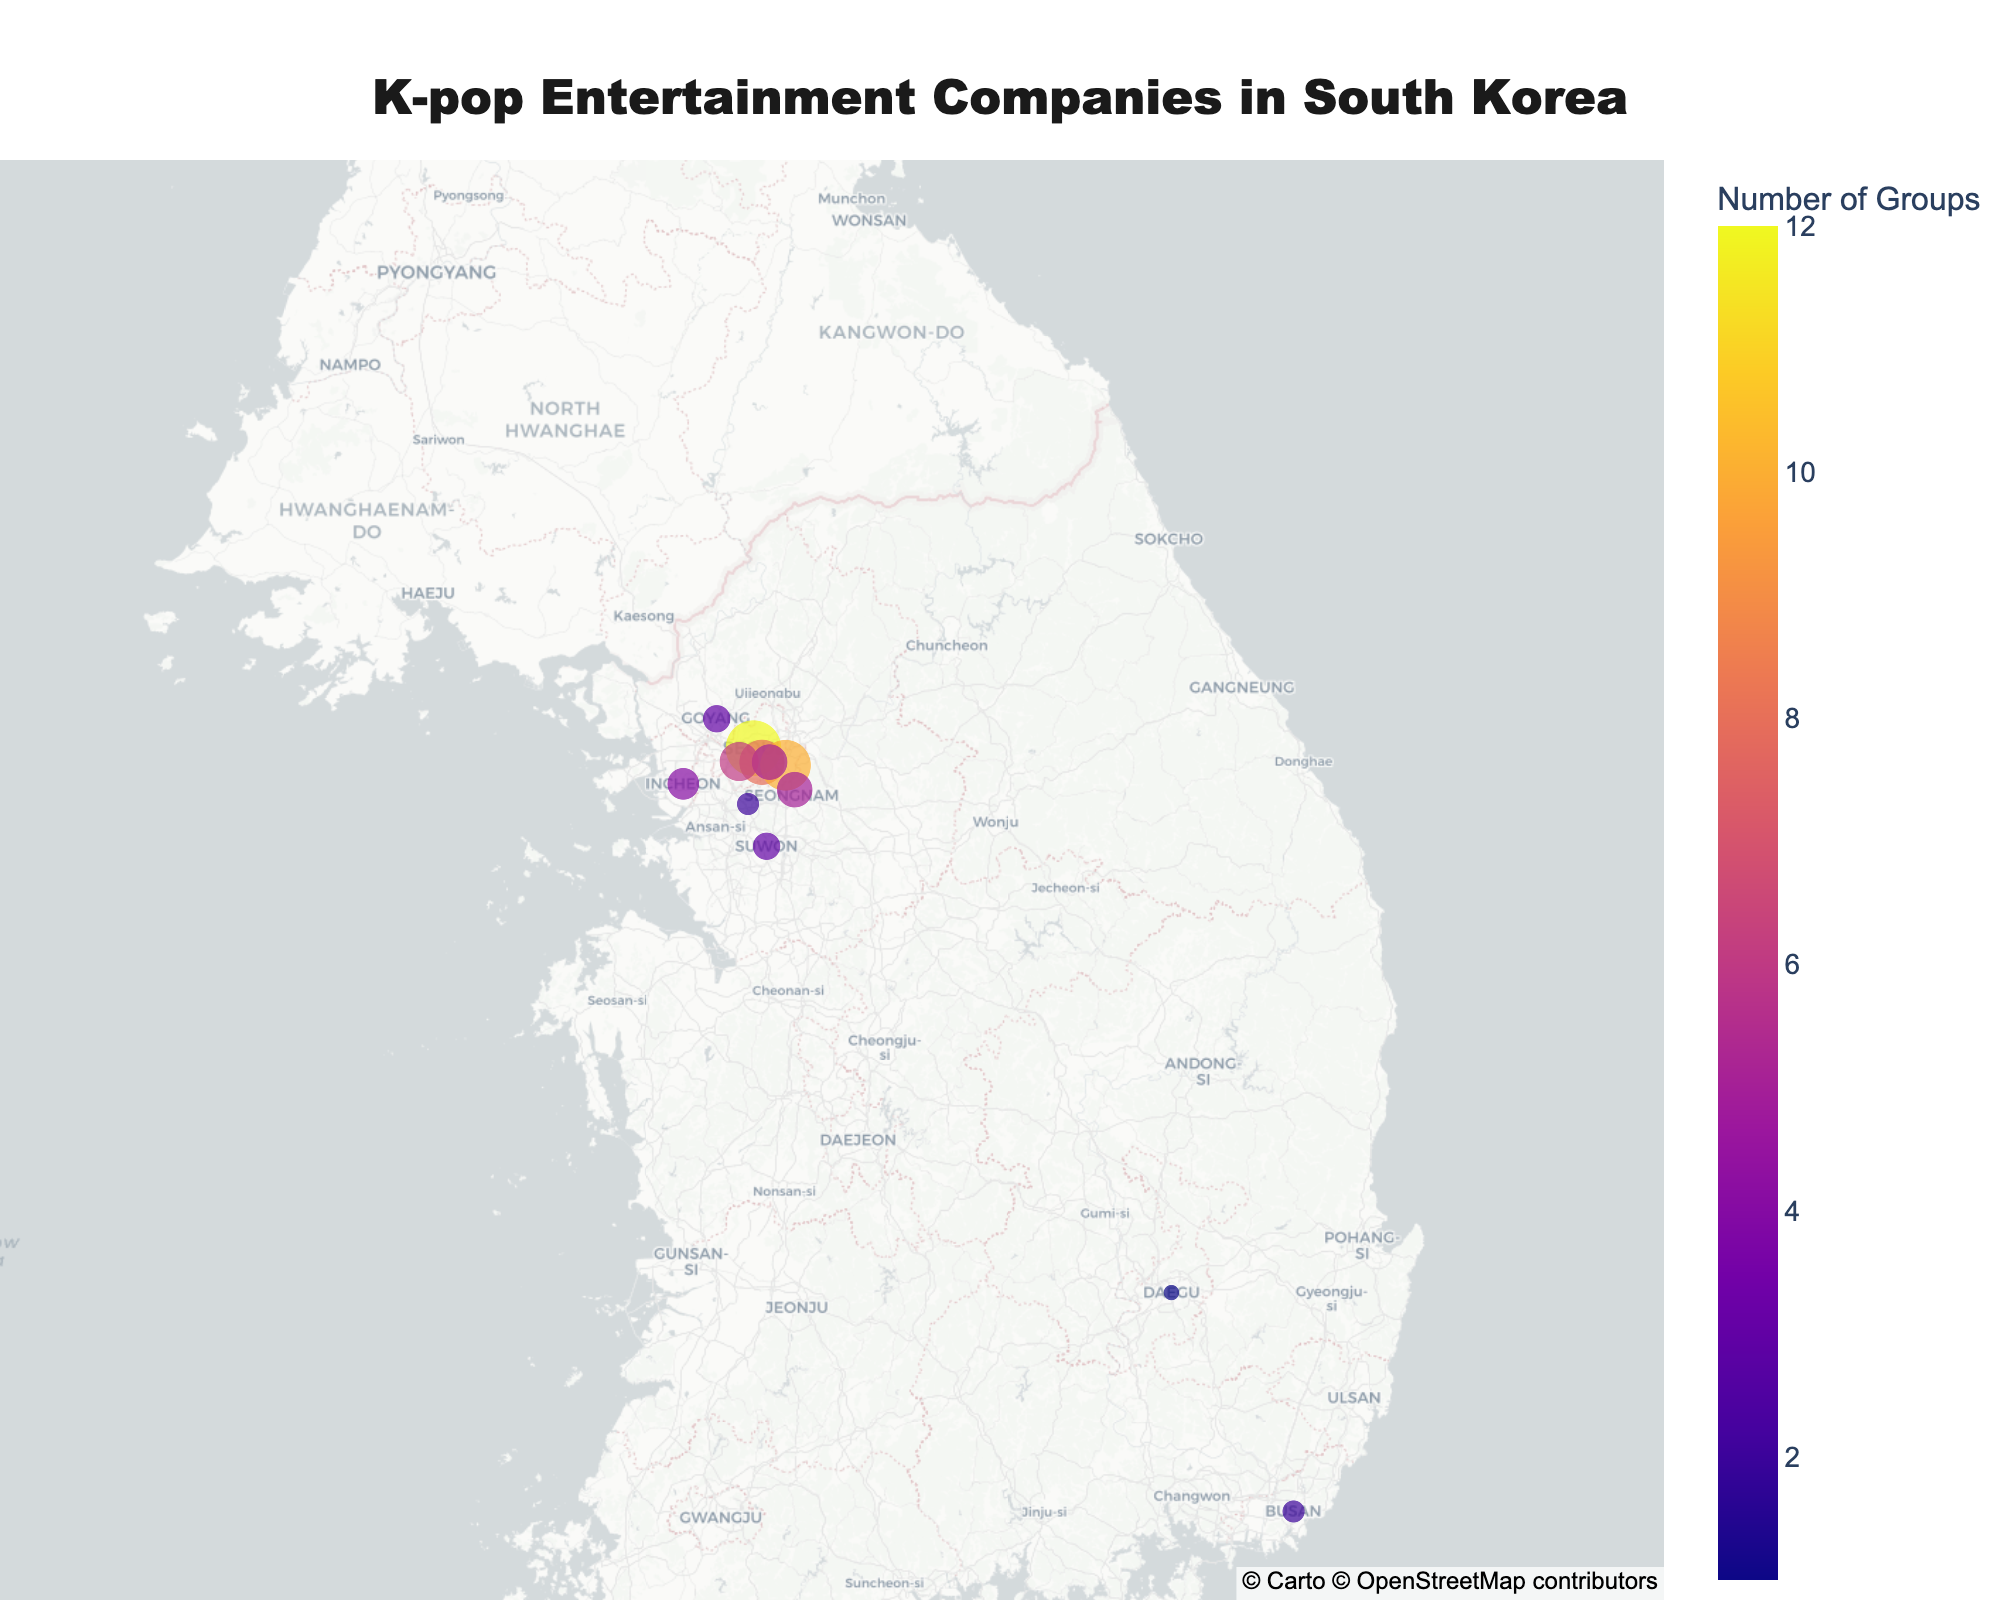How many K-pop entertainment companies are based in Seoul? Count the number of unique company labels shown around the Seoul region on the map. We can see SM Entertainment, YG Entertainment, JYP Entertainment, Big Hit Entertainment, and Cube Entertainment.
Answer: 5 Which city has the highest number of K-pop groups associated with it? Look at the sizes of the points on the map and the annotations indicating the number of groups per company. The city with large-sized points indicating a higher number of groups is Seoul.
Answer: Seoul Compare the number of groups managed by SM Entertainment and JYP Entertainment. Which one manages more? Identify the size and labels of SM Entertainment and JYP Entertainment on the map. SM Entertainment manages 12 groups, while JYP Entertainment manages 10.
Answer: SM Entertainment What is the average number of groups per company in this dataset? Sum the total number of groups and divide by the number of companies. The sum is 12+8+10+5+6+2+1+4+3+3+2+5 = 61. There are 12 companies. Thus, the average is 61/12.
Answer: 5.08 Does Busan have fewer K-pop groups than Seongnam? Compare the number of groups in Busan (KQ Entertainment with 2 groups) and Seongnam (FNC Entertainment with 5 groups).
Answer: Yes Which company manages the highest number of K-pop groups and where is it located? Check the size of the points indicating the number of groups and the associated labels. SM Entertainment has the largest point with 12 groups, located in Seoul.
Answer: SM Entertainment, Seoul How many cities other than Seoul have K-pop entertainment companies? Identify and count the unique city labels excluding Seoul. They are Busan, Daegu, Incheon, Goyang, Suwon, Anyang, and Seongnam, totaling 7 cities.
Answer: 7 What is the distribution of K-pop groups managed by entertainment companies in Gyeonggi Province (Goyang, Suwon, Anyang, Seongnam)? Sum the number of groups in Goyang (3), Suwon (3), Anyang (2), and Seongnam (5). Calculations: 3 + 3 + 2 + 5 = 13 groups.
Answer: 13 groups Which city among Daegu, Busan, and Anyang has the fewest K-pop groups? Compare the number of groups in Daegu (1), Busan (2), and Anyang (2). Daegu has the fewest.
Answer: Daegu 